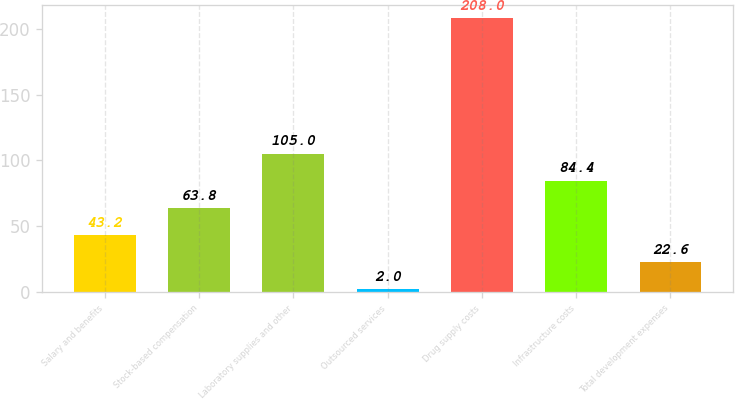Convert chart. <chart><loc_0><loc_0><loc_500><loc_500><bar_chart><fcel>Salary and benefits<fcel>Stock-based compensation<fcel>Laboratory supplies and other<fcel>Outsourced services<fcel>Drug supply costs<fcel>Infrastructure costs<fcel>Total development expenses<nl><fcel>43.2<fcel>63.8<fcel>105<fcel>2<fcel>208<fcel>84.4<fcel>22.6<nl></chart> 